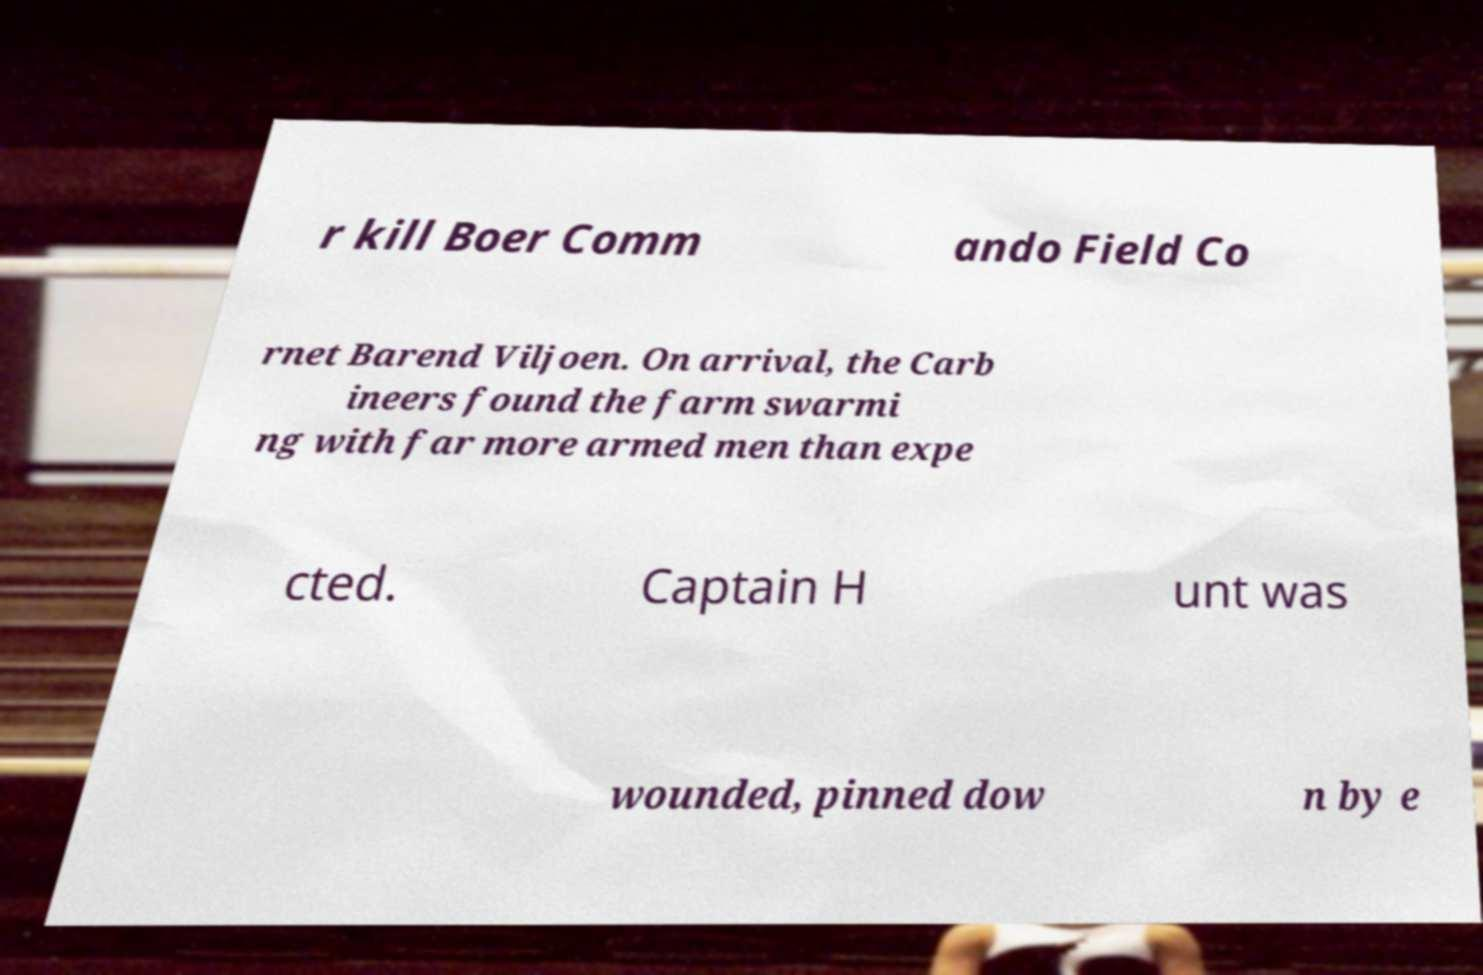What messages or text are displayed in this image? I need them in a readable, typed format. r kill Boer Comm ando Field Co rnet Barend Viljoen. On arrival, the Carb ineers found the farm swarmi ng with far more armed men than expe cted. Captain H unt was wounded, pinned dow n by e 